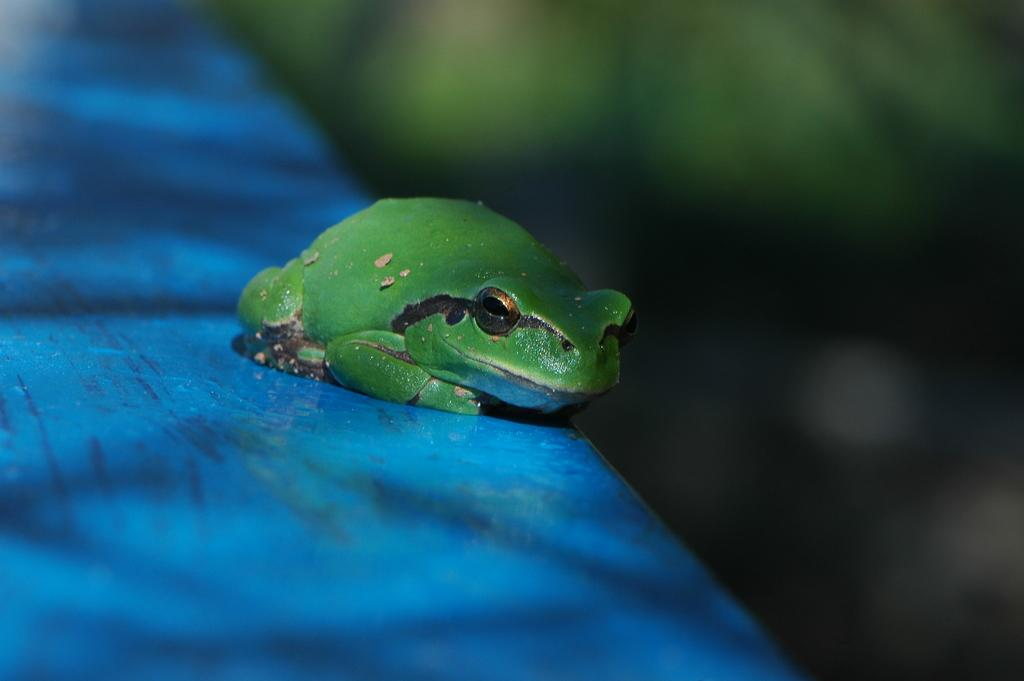What color dominates the foreground of the image? The foreground of the image has a blue color. What type of animal can be seen in the image? There is a frog in the image. What is the color of the frog? The frog is green in color. Is there any part of the image that is not clear? Yes, the image is blurry on the right side. What type of ship can be seen sailing in the background of the image? There is no ship visible in the image; it only features a frog and a blue foreground. What range of motion does the frog exhibit in the image? The image is a still photograph, so the frog's motion cannot be determined. 